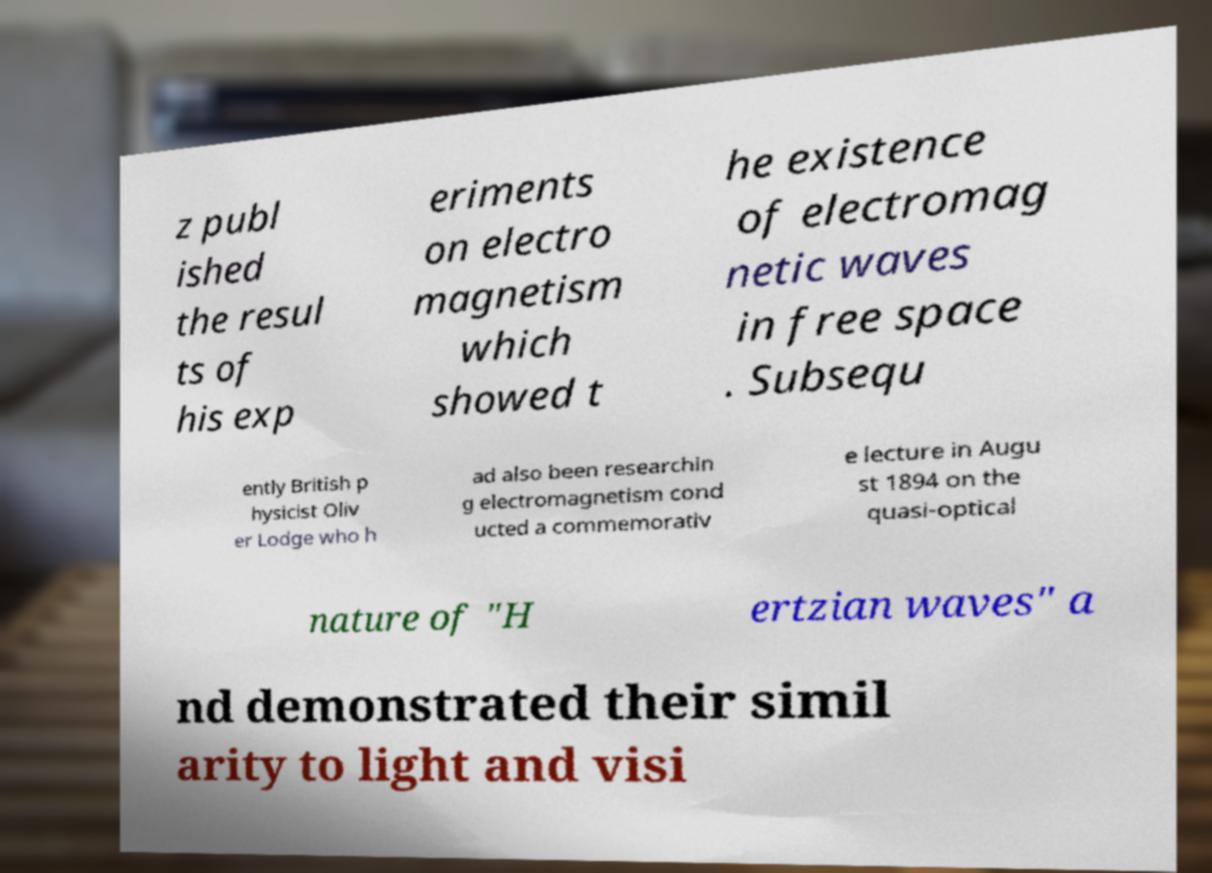Please identify and transcribe the text found in this image. z publ ished the resul ts of his exp eriments on electro magnetism which showed t he existence of electromag netic waves in free space . Subsequ ently British p hysicist Oliv er Lodge who h ad also been researchin g electromagnetism cond ucted a commemorativ e lecture in Augu st 1894 on the quasi-optical nature of "H ertzian waves" a nd demonstrated their simil arity to light and visi 